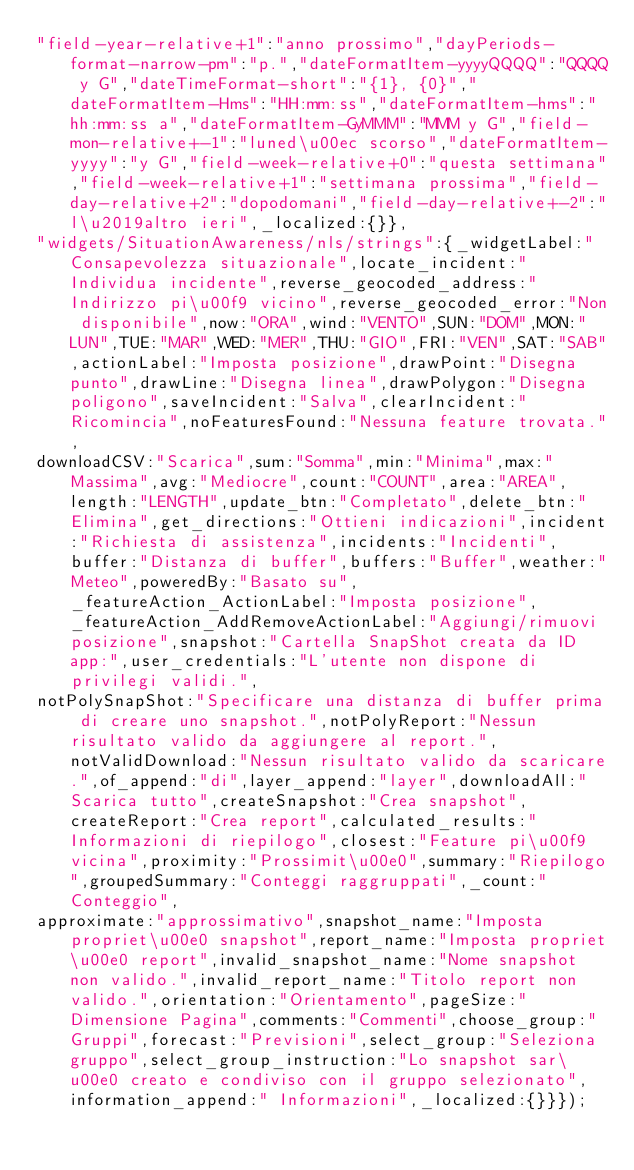<code> <loc_0><loc_0><loc_500><loc_500><_JavaScript_>"field-year-relative+1":"anno prossimo","dayPeriods-format-narrow-pm":"p.","dateFormatItem-yyyyQQQQ":"QQQQ y G","dateTimeFormat-short":"{1}, {0}","dateFormatItem-Hms":"HH:mm:ss","dateFormatItem-hms":"hh:mm:ss a","dateFormatItem-GyMMM":"MMM y G","field-mon-relative+-1":"luned\u00ec scorso","dateFormatItem-yyyy":"y G","field-week-relative+0":"questa settimana","field-week-relative+1":"settimana prossima","field-day-relative+2":"dopodomani","field-day-relative+-2":"l\u2019altro ieri",_localized:{}},
"widgets/SituationAwareness/nls/strings":{_widgetLabel:"Consapevolezza situazionale",locate_incident:"Individua incidente",reverse_geocoded_address:"Indirizzo pi\u00f9 vicino",reverse_geocoded_error:"Non disponibile",now:"ORA",wind:"VENTO",SUN:"DOM",MON:"LUN",TUE:"MAR",WED:"MER",THU:"GIO",FRI:"VEN",SAT:"SAB",actionLabel:"Imposta posizione",drawPoint:"Disegna punto",drawLine:"Disegna linea",drawPolygon:"Disegna poligono",saveIncident:"Salva",clearIncident:"Ricomincia",noFeaturesFound:"Nessuna feature trovata.",
downloadCSV:"Scarica",sum:"Somma",min:"Minima",max:"Massima",avg:"Mediocre",count:"COUNT",area:"AREA",length:"LENGTH",update_btn:"Completato",delete_btn:"Elimina",get_directions:"Ottieni indicazioni",incident:"Richiesta di assistenza",incidents:"Incidenti",buffer:"Distanza di buffer",buffers:"Buffer",weather:"Meteo",poweredBy:"Basato su",_featureAction_ActionLabel:"Imposta posizione",_featureAction_AddRemoveActionLabel:"Aggiungi/rimuovi posizione",snapshot:"Cartella SnapShot creata da ID app:",user_credentials:"L'utente non dispone di privilegi validi.",
notPolySnapShot:"Specificare una distanza di buffer prima di creare uno snapshot.",notPolyReport:"Nessun risultato valido da aggiungere al report.",notValidDownload:"Nessun risultato valido da scaricare.",of_append:"di",layer_append:"layer",downloadAll:"Scarica tutto",createSnapshot:"Crea snapshot",createReport:"Crea report",calculated_results:"Informazioni di riepilogo",closest:"Feature pi\u00f9 vicina",proximity:"Prossimit\u00e0",summary:"Riepilogo",groupedSummary:"Conteggi raggruppati",_count:"Conteggio",
approximate:"approssimativo",snapshot_name:"Imposta propriet\u00e0 snapshot",report_name:"Imposta propriet\u00e0 report",invalid_snapshot_name:"Nome snapshot non valido.",invalid_report_name:"Titolo report non valido.",orientation:"Orientamento",pageSize:"Dimensione Pagina",comments:"Commenti",choose_group:"Gruppi",forecast:"Previsioni",select_group:"Seleziona gruppo",select_group_instruction:"Lo snapshot sar\u00e0 creato e condiviso con il gruppo selezionato",information_append:" Informazioni",_localized:{}}});</code> 